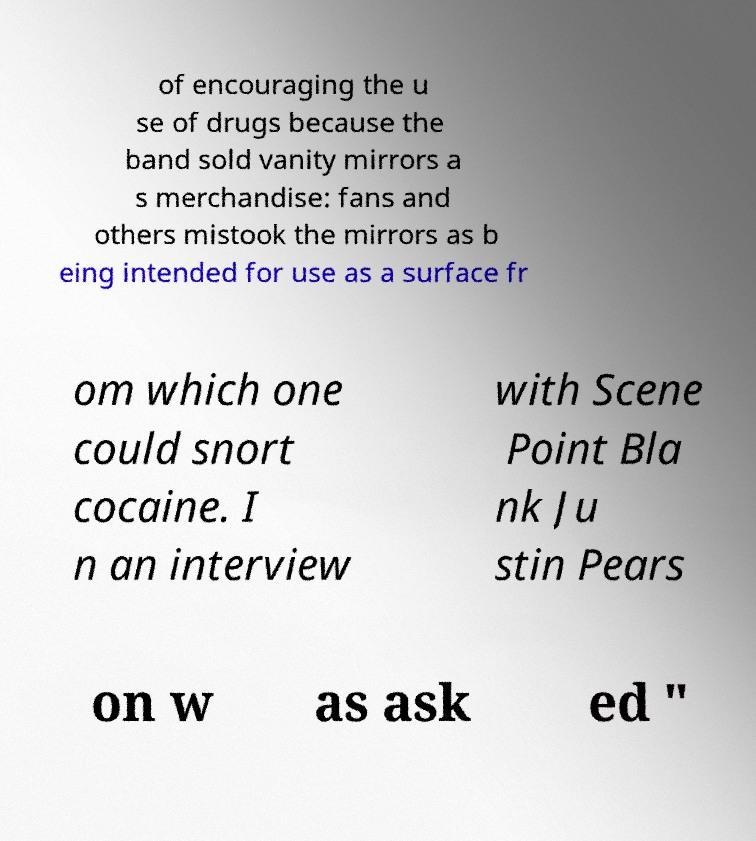Can you read and provide the text displayed in the image?This photo seems to have some interesting text. Can you extract and type it out for me? of encouraging the u se of drugs because the band sold vanity mirrors a s merchandise: fans and others mistook the mirrors as b eing intended for use as a surface fr om which one could snort cocaine. I n an interview with Scene Point Bla nk Ju stin Pears on w as ask ed " 